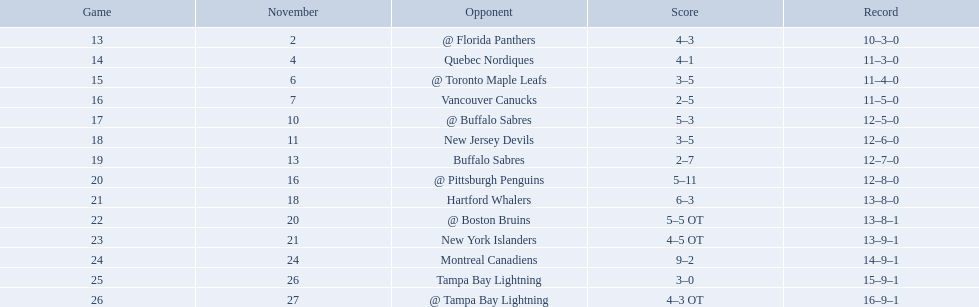What are the teams in the atlantic division? Quebec Nordiques, Vancouver Canucks, New Jersey Devils, Buffalo Sabres, Hartford Whalers, New York Islanders, Montreal Canadiens, Tampa Bay Lightning. Which of those scored fewer points than the philadelphia flyers? Tampa Bay Lightning. What were the scores of the 1993-94 philadelphia flyers season? 4–3, 4–1, 3–5, 2–5, 5–3, 3–5, 2–7, 5–11, 6–3, 5–5 OT, 4–5 OT, 9–2, 3–0, 4–3 OT. Which of these teams had the score 4-5 ot? New York Islanders. What were the scores? @ Florida Panthers, 4–3, Quebec Nordiques, 4–1, @ Toronto Maple Leafs, 3–5, Vancouver Canucks, 2–5, @ Buffalo Sabres, 5–3, New Jersey Devils, 3–5, Buffalo Sabres, 2–7, @ Pittsburgh Penguins, 5–11, Hartford Whalers, 6–3, @ Boston Bruins, 5–5 OT, New York Islanders, 4–5 OT, Montreal Canadiens, 9–2, Tampa Bay Lightning, 3–0, @ Tampa Bay Lightning, 4–3 OT. What score was the closest? New York Islanders, 4–5 OT. What team had that score? New York Islanders. 